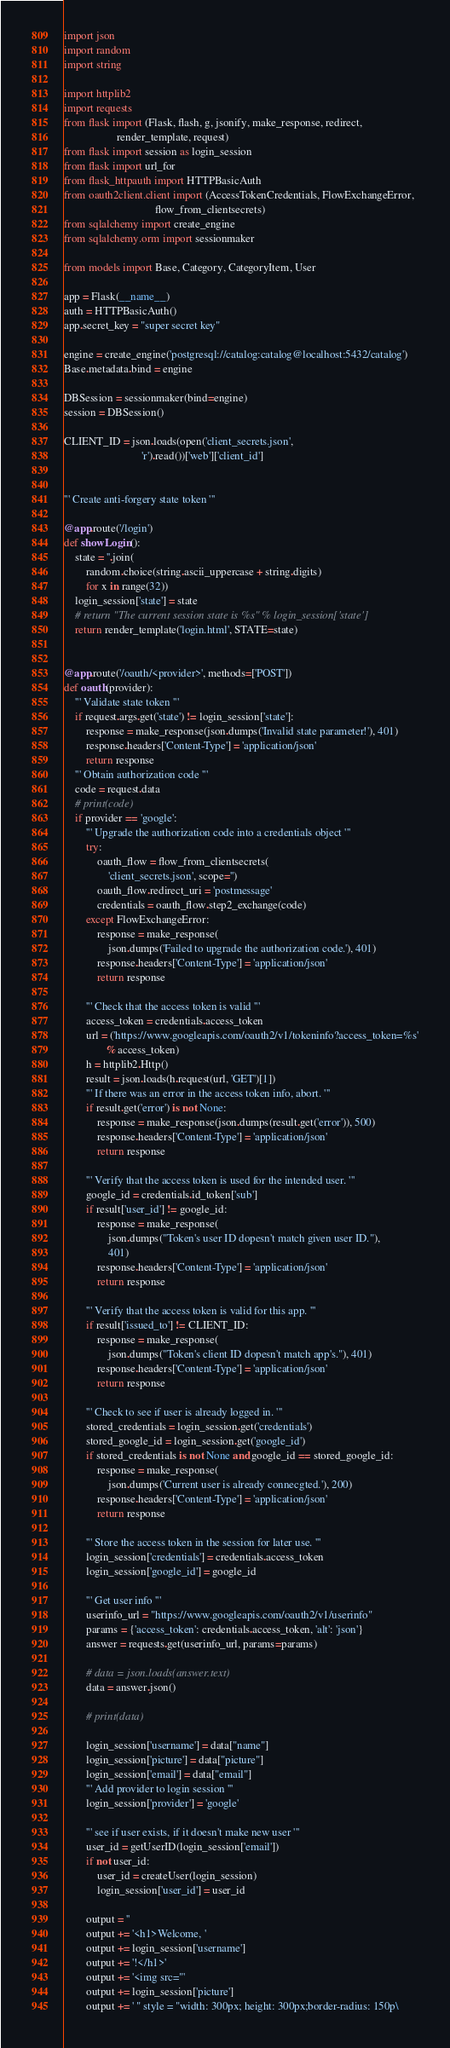<code> <loc_0><loc_0><loc_500><loc_500><_Python_>import json
import random
import string

import httplib2
import requests
from flask import (Flask, flash, g, jsonify, make_response, redirect,
                   render_template, request)
from flask import session as login_session
from flask import url_for
from flask_httpauth import HTTPBasicAuth
from oauth2client.client import (AccessTokenCredentials, FlowExchangeError,
                                 flow_from_clientsecrets)
from sqlalchemy import create_engine
from sqlalchemy.orm import sessionmaker

from models import Base, Category, CategoryItem, User

app = Flask(__name__)
auth = HTTPBasicAuth()
app.secret_key = "super secret key"

engine = create_engine('postgresql://catalog:catalog@localhost:5432/catalog')
Base.metadata.bind = engine

DBSession = sessionmaker(bind=engine)
session = DBSession()

CLIENT_ID = json.loads(open('client_secrets.json',
                            'r').read())['web']['client_id']


''' Create anti-forgery state token '''

@app.route('/login')
def showLogin():
    state = ''.join(
        random.choice(string.ascii_uppercase + string.digits)
        for x in range(32))
    login_session['state'] = state
    # return "The current session state is %s" % login_session['state']
    return render_template('login.html', STATE=state)


@app.route('/oauth/<provider>', methods=['POST'])
def oauth(provider):
    ''' Validate state token '''
    if request.args.get('state') != login_session['state']:
        response = make_response(json.dumps('Invalid state parameter!'), 401)
        response.headers['Content-Type'] = 'application/json'
        return response
    ''' Obtain authorization code '''
    code = request.data
    # print(code)
    if provider == 'google':
        ''' Upgrade the authorization code into a credentials object '''
        try:
            oauth_flow = flow_from_clientsecrets(
                'client_secrets.json', scope='')
            oauth_flow.redirect_uri = 'postmessage'
            credentials = oauth_flow.step2_exchange(code)
        except FlowExchangeError:
            response = make_response(
                json.dumps('Failed to upgrade the authorization code.'), 401)
            response.headers['Content-Type'] = 'application/json'
            return response

        ''' Check that the access token is valid '''
        access_token = credentials.access_token
        url = ('https://www.googleapis.com/oauth2/v1/tokeninfo?access_token=%s'
               % access_token)
        h = httplib2.Http()
        result = json.loads(h.request(url, 'GET')[1])
        ''' If there was an error in the access token info, abort. '''
        if result.get('error') is not None:
            response = make_response(json.dumps(result.get('error')), 500)
            response.headers['Content-Type'] = 'application/json'
            return response

        ''' Verify that the access token is used for the intended user. '''
        google_id = credentials.id_token['sub']
        if result['user_id'] != google_id:
            response = make_response(
                json.dumps("Token's user ID dopesn't match given user ID."),
                401)
            response.headers['Content-Type'] = 'application/json'
            return response

        ''' Verify that the access token is valid for this app. '''
        if result['issued_to'] != CLIENT_ID:
            response = make_response(
                json.dumps("Token's client ID dopesn't match app's."), 401)
            response.headers['Content-Type'] = 'application/json'
            return response

        ''' Check to see if user is already logged in. '''
        stored_credentials = login_session.get('credentials')
        stored_google_id = login_session.get('google_id')
        if stored_credentials is not None and google_id == stored_google_id:
            response = make_response(
                json.dumps('Current user is already connecgted.'), 200)
            response.headers['Content-Type'] = 'application/json'
            return response

        ''' Store the access token in the session for later use. '''
        login_session['credentials'] = credentials.access_token
        login_session['google_id'] = google_id

        ''' Get user info '''
        userinfo_url = "https://www.googleapis.com/oauth2/v1/userinfo"
        params = {'access_token': credentials.access_token, 'alt': 'json'}
        answer = requests.get(userinfo_url, params=params)

        # data = json.loads(answer.text)
        data = answer.json()

        # print(data)

        login_session['username'] = data["name"]
        login_session['picture'] = data["picture"]
        login_session['email'] = data["email"]
        ''' Add provider to login session '''
        login_session['provider'] = 'google'

        ''' see if user exists, if it doesn't make new user '''
        user_id = getUserID(login_session['email'])
        if not user_id:
            user_id = createUser(login_session)
            login_session['user_id'] = user_id

        output = ''
        output += '<h1>Welcome, '
        output += login_session['username']
        output += '!</h1>'
        output += '<img src="'
        output += login_session['picture']
        output += ' " style = "width: 300px; height: 300px;border-radius: 150p\</code> 